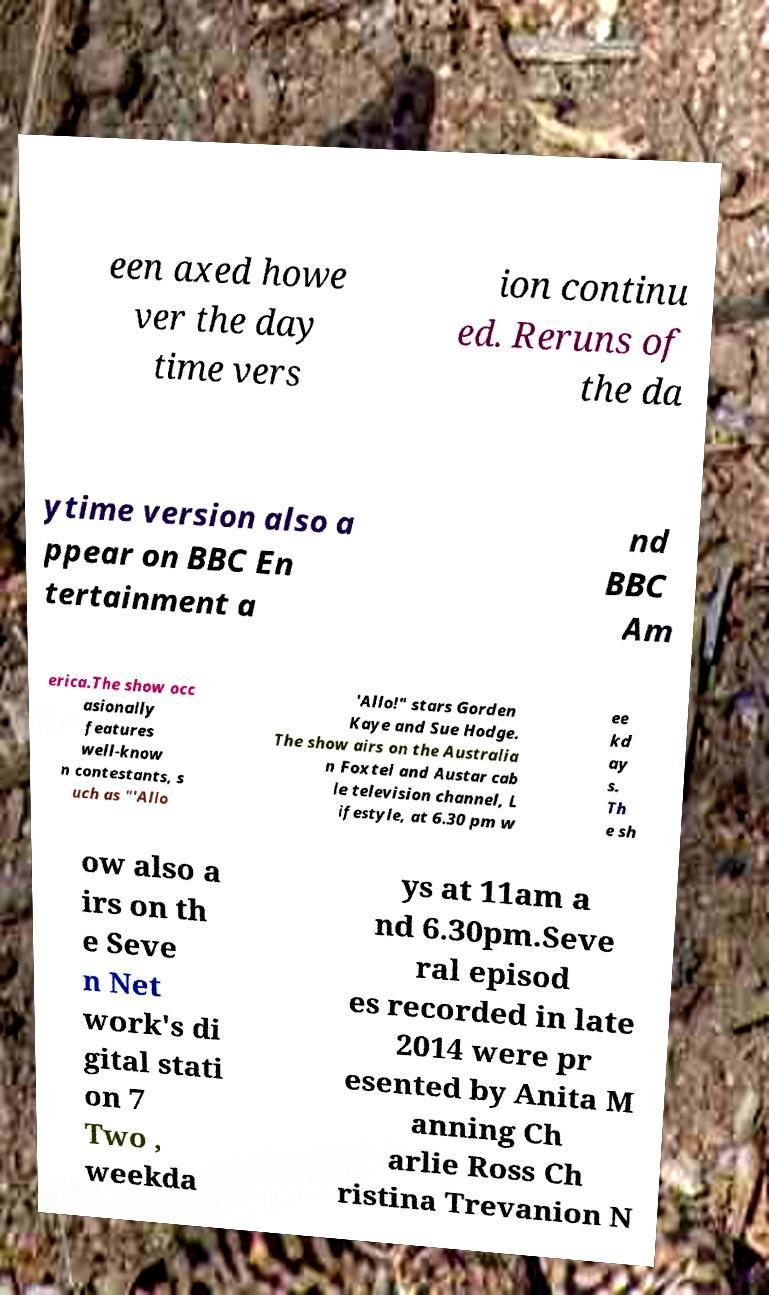Please identify and transcribe the text found in this image. een axed howe ver the day time vers ion continu ed. Reruns of the da ytime version also a ppear on BBC En tertainment a nd BBC Am erica.The show occ asionally features well-know n contestants, s uch as "'Allo 'Allo!" stars Gorden Kaye and Sue Hodge. The show airs on the Australia n Foxtel and Austar cab le television channel, L ifestyle, at 6.30 pm w ee kd ay s. Th e sh ow also a irs on th e Seve n Net work's di gital stati on 7 Two , weekda ys at 11am a nd 6.30pm.Seve ral episod es recorded in late 2014 were pr esented by Anita M anning Ch arlie Ross Ch ristina Trevanion N 